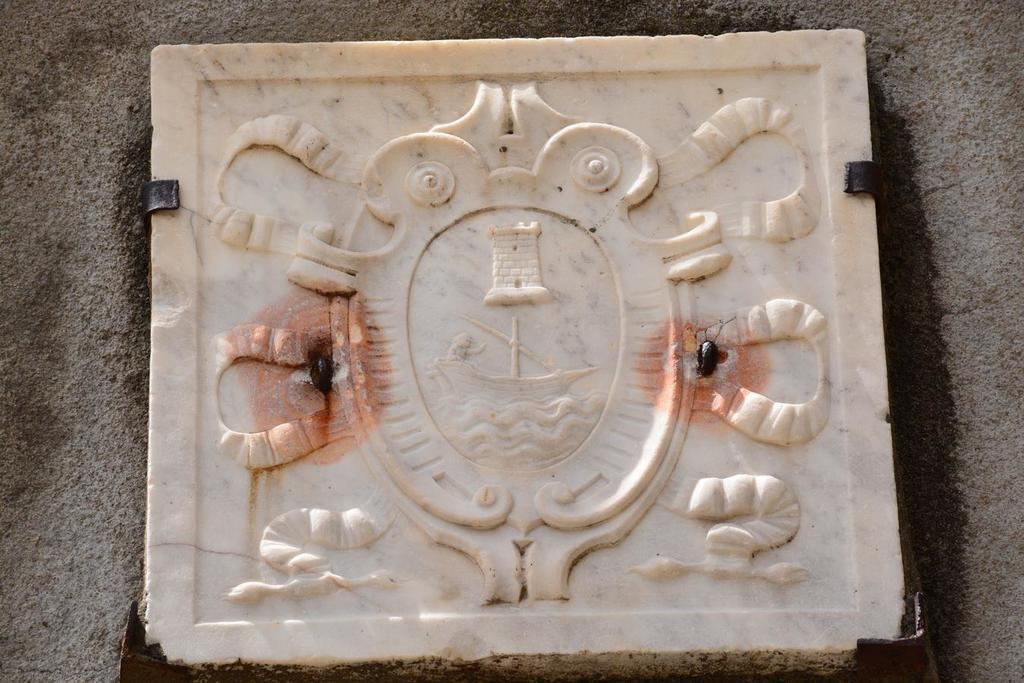What material is the main object in the image made of? The main object in the image is made of carved marble stone. What is the price of the apples in the image? There are no apples present in the image, so it is not possible to determine their price. 